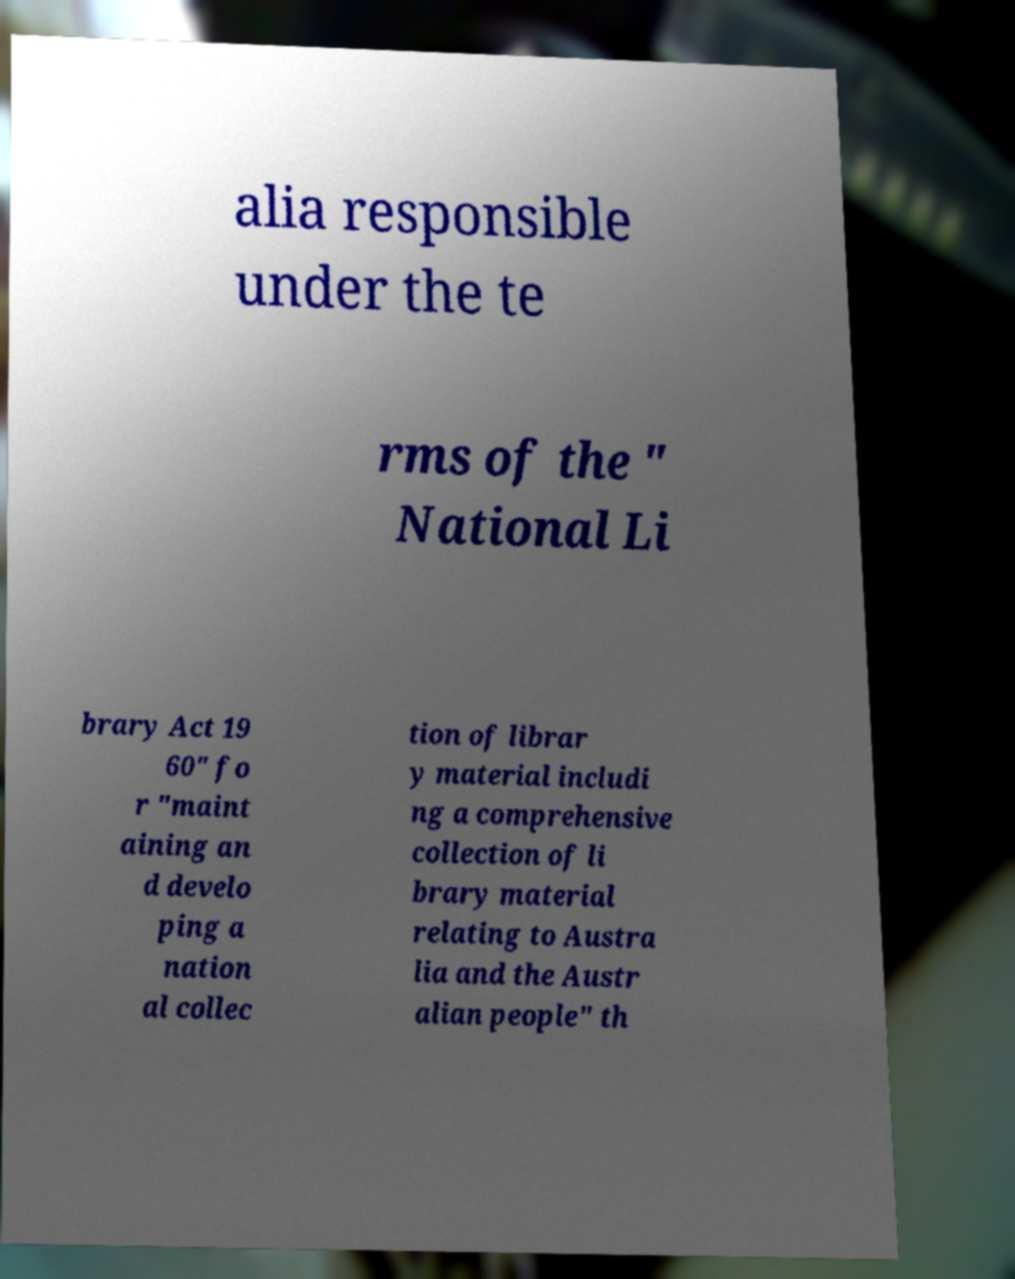Could you assist in decoding the text presented in this image and type it out clearly? alia responsible under the te rms of the " National Li brary Act 19 60" fo r "maint aining an d develo ping a nation al collec tion of librar y material includi ng a comprehensive collection of li brary material relating to Austra lia and the Austr alian people" th 